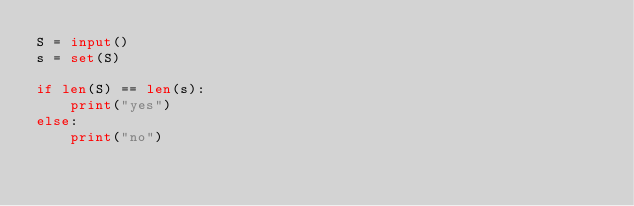<code> <loc_0><loc_0><loc_500><loc_500><_Python_>S = input()
s = set(S)

if len(S) == len(s):
    print("yes")
else:
    print("no")
</code> 